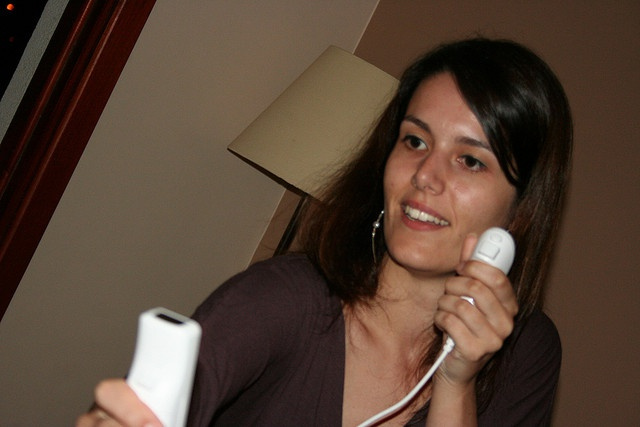Describe the objects in this image and their specific colors. I can see people in black, gray, tan, and maroon tones and remote in black, white, darkgray, and gray tones in this image. 